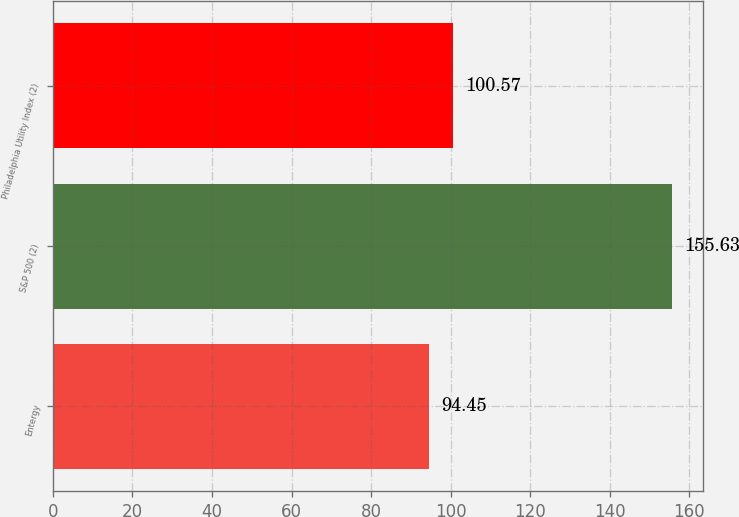Convert chart. <chart><loc_0><loc_0><loc_500><loc_500><bar_chart><fcel>Entergy<fcel>S&P 500 (2)<fcel>Philadelphia Utility Index (2)<nl><fcel>94.45<fcel>155.63<fcel>100.57<nl></chart> 